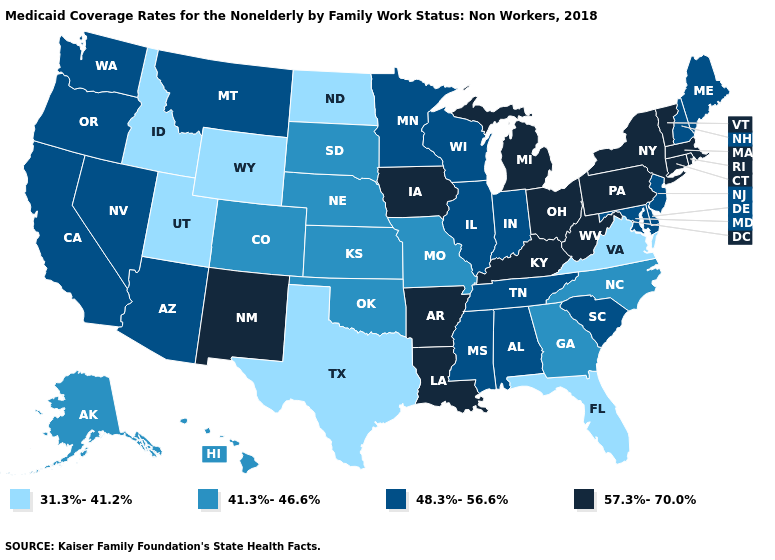Name the states that have a value in the range 41.3%-46.6%?
Concise answer only. Alaska, Colorado, Georgia, Hawaii, Kansas, Missouri, Nebraska, North Carolina, Oklahoma, South Dakota. Name the states that have a value in the range 41.3%-46.6%?
Keep it brief. Alaska, Colorado, Georgia, Hawaii, Kansas, Missouri, Nebraska, North Carolina, Oklahoma, South Dakota. Name the states that have a value in the range 48.3%-56.6%?
Write a very short answer. Alabama, Arizona, California, Delaware, Illinois, Indiana, Maine, Maryland, Minnesota, Mississippi, Montana, Nevada, New Hampshire, New Jersey, Oregon, South Carolina, Tennessee, Washington, Wisconsin. Does New York have a higher value than Oregon?
Answer briefly. Yes. Does the map have missing data?
Write a very short answer. No. Among the states that border Nevada , does Oregon have the highest value?
Short answer required. Yes. Name the states that have a value in the range 48.3%-56.6%?
Be succinct. Alabama, Arizona, California, Delaware, Illinois, Indiana, Maine, Maryland, Minnesota, Mississippi, Montana, Nevada, New Hampshire, New Jersey, Oregon, South Carolina, Tennessee, Washington, Wisconsin. Is the legend a continuous bar?
Quick response, please. No. Does the map have missing data?
Give a very brief answer. No. What is the value of Virginia?
Answer briefly. 31.3%-41.2%. Name the states that have a value in the range 57.3%-70.0%?
Be succinct. Arkansas, Connecticut, Iowa, Kentucky, Louisiana, Massachusetts, Michigan, New Mexico, New York, Ohio, Pennsylvania, Rhode Island, Vermont, West Virginia. What is the lowest value in the USA?
Be succinct. 31.3%-41.2%. Does Oklahoma have the lowest value in the South?
Give a very brief answer. No. Does Iowa have a lower value than Rhode Island?
Answer briefly. No. Does Hawaii have the highest value in the USA?
Short answer required. No. 